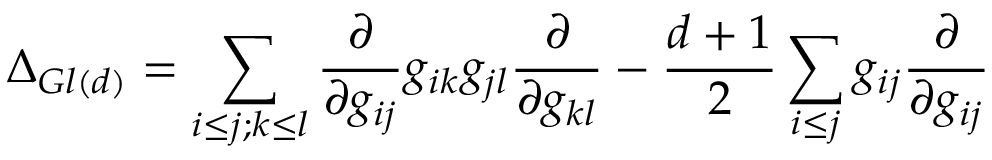Convert formula to latex. <formula><loc_0><loc_0><loc_500><loc_500>\Delta _ { G l ( d ) } = \sum _ { i \leq j ; k \leq l } \frac { \partial } { \partial g _ { i j } } g _ { i k } g _ { j l } \frac { \partial } { \partial g _ { k l } } - \frac { d + 1 } { 2 } \sum _ { i \leq j } g _ { i j } \frac { \partial } { \partial g _ { i j } }</formula> 